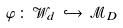<formula> <loc_0><loc_0><loc_500><loc_500>\varphi \, \colon \, \mathcal { W } _ { d } \, \hookrightarrow \, \mathcal { M } _ { D }</formula> 